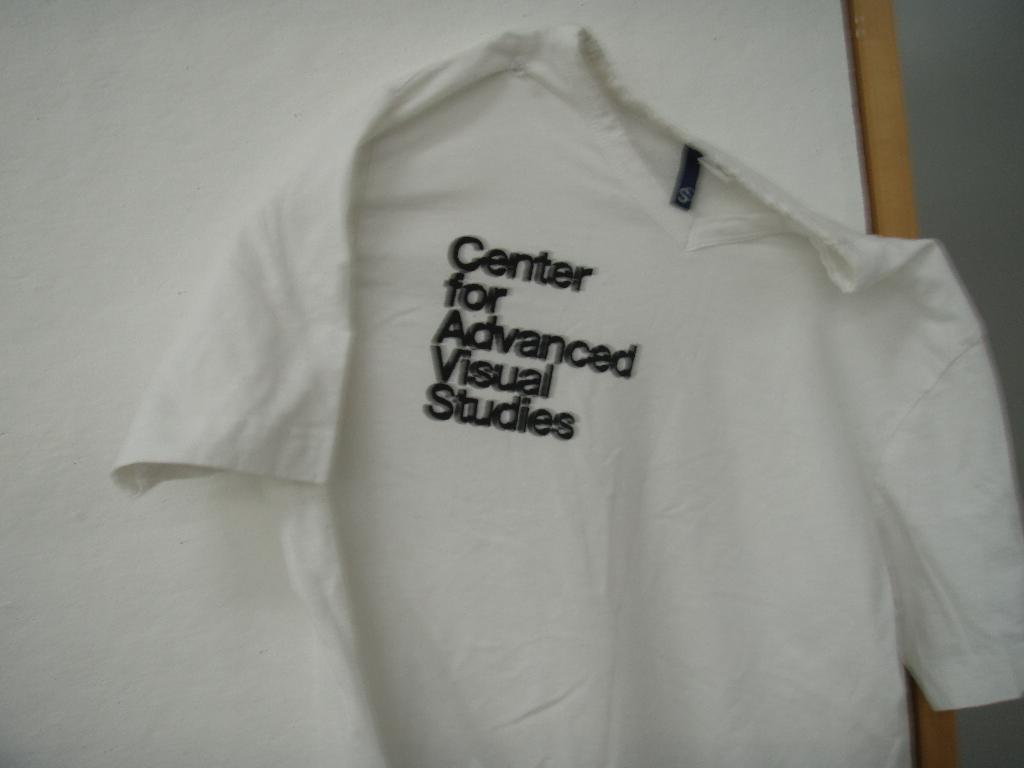<image>
Share a concise interpretation of the image provided. A white t-shirt advertises the Center for Advanced Visual Studies. 